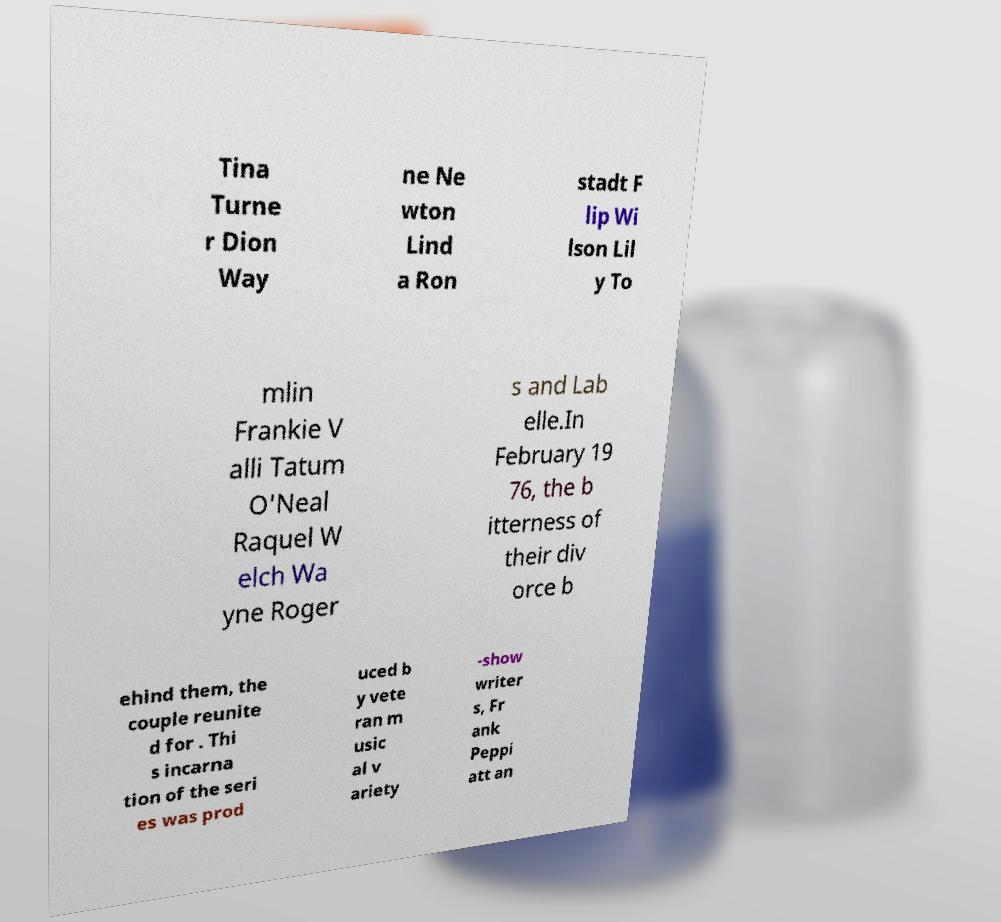Could you assist in decoding the text presented in this image and type it out clearly? Tina Turne r Dion Way ne Ne wton Lind a Ron stadt F lip Wi lson Lil y To mlin Frankie V alli Tatum O'Neal Raquel W elch Wa yne Roger s and Lab elle.In February 19 76, the b itterness of their div orce b ehind them, the couple reunite d for . Thi s incarna tion of the seri es was prod uced b y vete ran m usic al v ariety -show writer s, Fr ank Peppi att an 